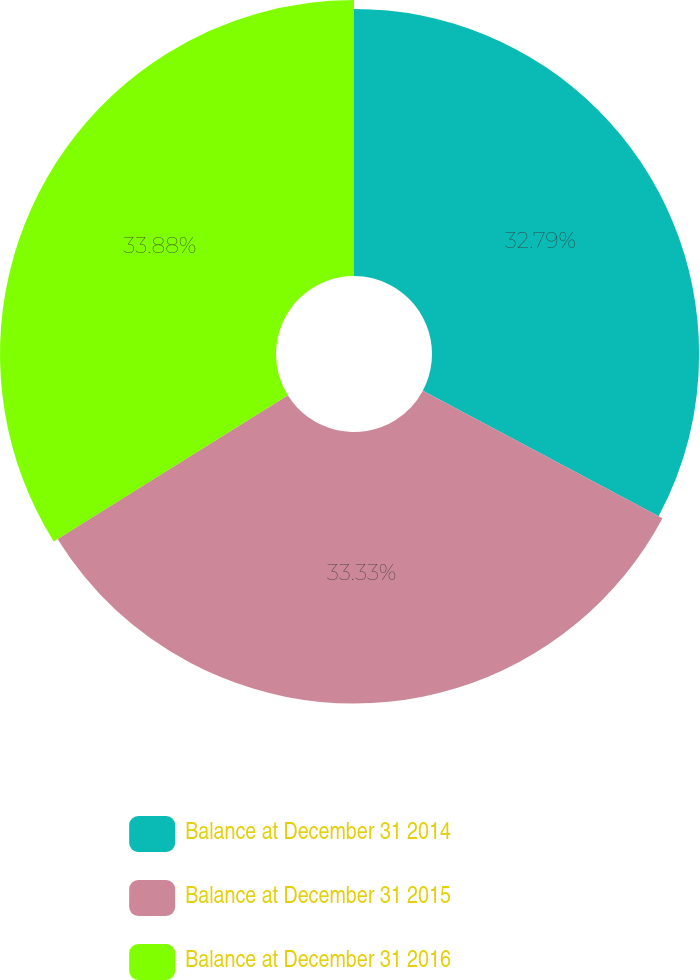Convert chart to OTSL. <chart><loc_0><loc_0><loc_500><loc_500><pie_chart><fcel>Balance at December 31 2014<fcel>Balance at December 31 2015<fcel>Balance at December 31 2016<nl><fcel>32.79%<fcel>33.33%<fcel>33.88%<nl></chart> 